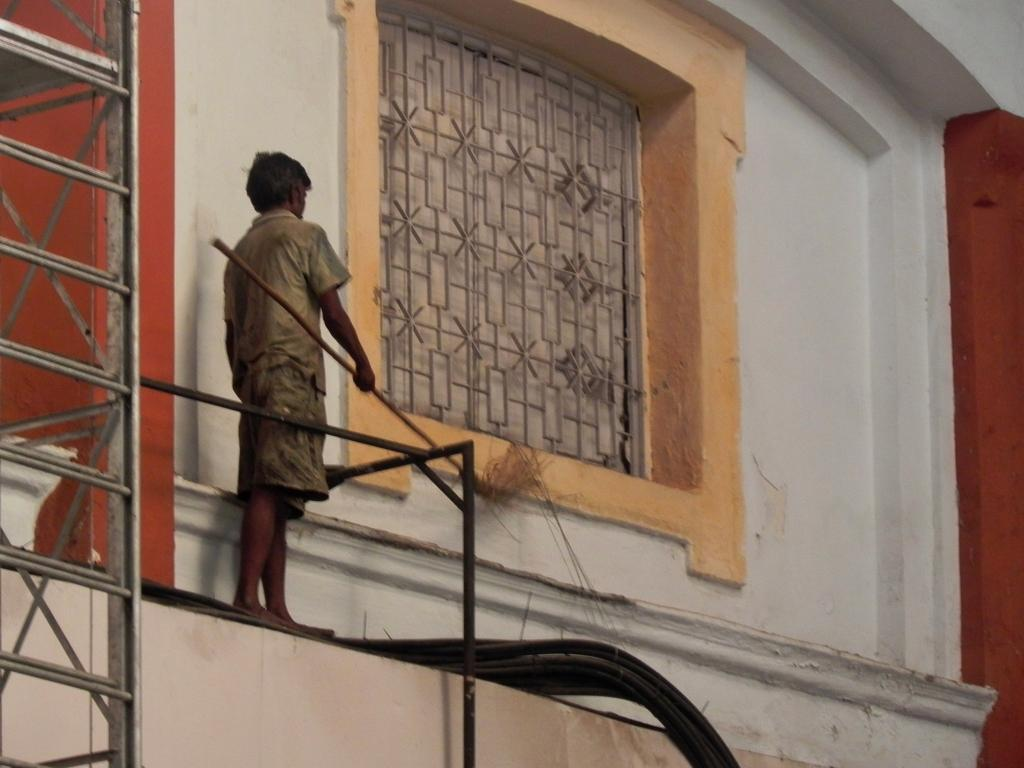What is the person in the image holding? The person is holding a broom. Can you describe the window in the image? There is a window in the image, and it has a grill. How much oil is visible in the image? There is no oil present in the image. Can you see a nest in the image? There is no nest present in the image. 